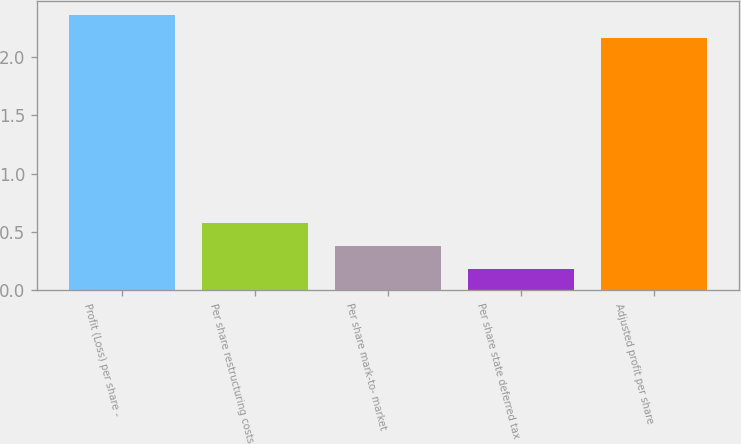<chart> <loc_0><loc_0><loc_500><loc_500><bar_chart><fcel>Profit (Loss) per share -<fcel>Per share restructuring costs<fcel>Per share mark-to- market<fcel>Per share state deferred tax<fcel>Adjusted profit per share<nl><fcel>2.36<fcel>0.58<fcel>0.38<fcel>0.18<fcel>2.16<nl></chart> 